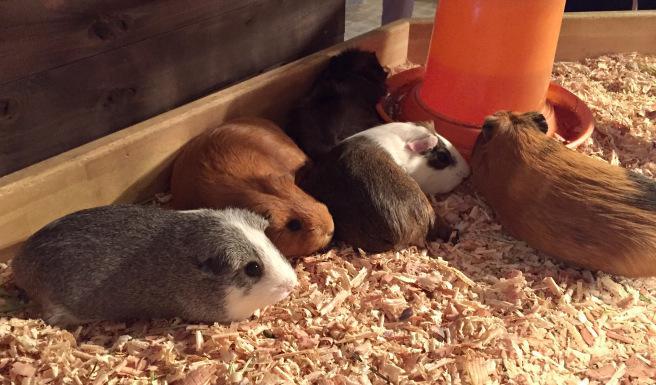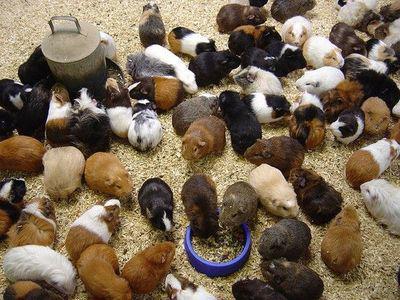The first image is the image on the left, the second image is the image on the right. Evaluate the accuracy of this statement regarding the images: "Left image contains no more than five hamsters, which are in a wood-sided enclosure.". Is it true? Answer yes or no. Yes. The first image is the image on the left, the second image is the image on the right. Given the left and right images, does the statement "At least one of the pictures shows less than 10 rodents." hold true? Answer yes or no. Yes. 